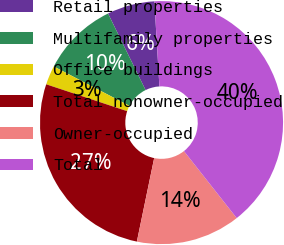Convert chart. <chart><loc_0><loc_0><loc_500><loc_500><pie_chart><fcel>Retail properties<fcel>Multifamily properties<fcel>Office buildings<fcel>Total nonowner-occupied<fcel>Owner-occupied<fcel>Total<nl><fcel>6.32%<fcel>10.1%<fcel>2.54%<fcel>26.85%<fcel>13.87%<fcel>40.32%<nl></chart> 